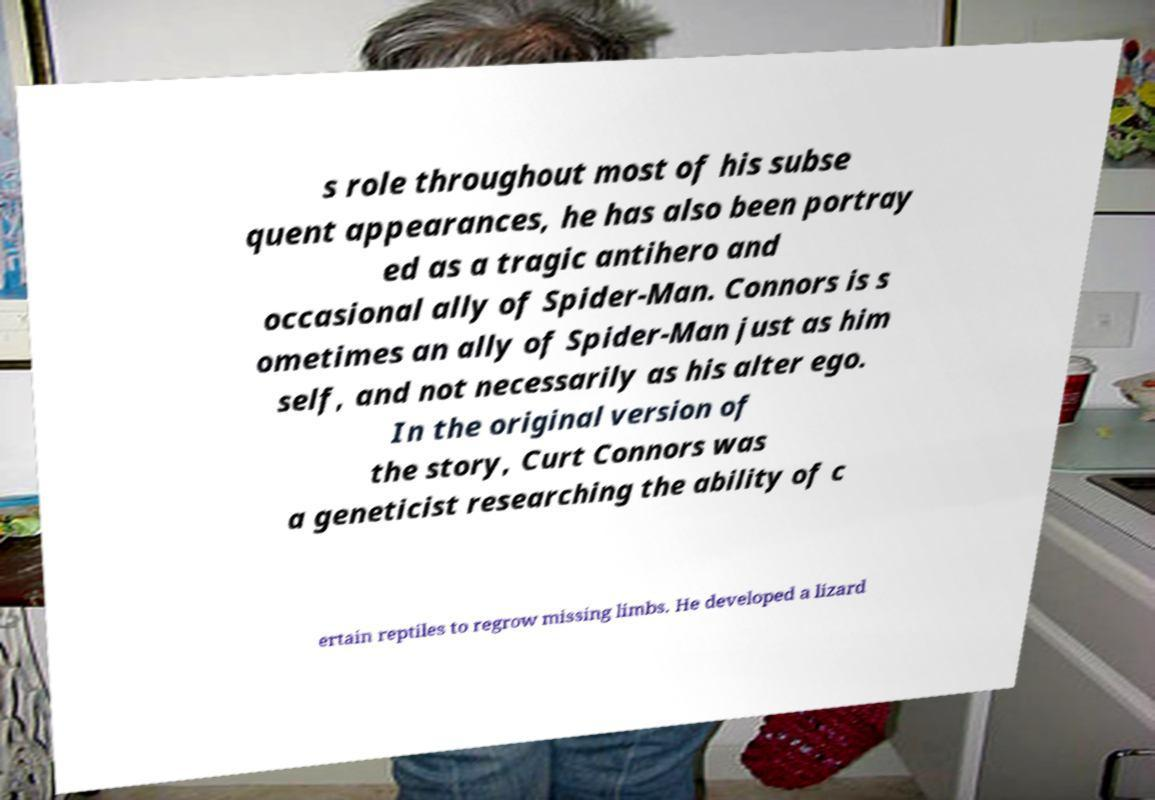What messages or text are displayed in this image? I need them in a readable, typed format. s role throughout most of his subse quent appearances, he has also been portray ed as a tragic antihero and occasional ally of Spider-Man. Connors is s ometimes an ally of Spider-Man just as him self, and not necessarily as his alter ego. In the original version of the story, Curt Connors was a geneticist researching the ability of c ertain reptiles to regrow missing limbs. He developed a lizard 